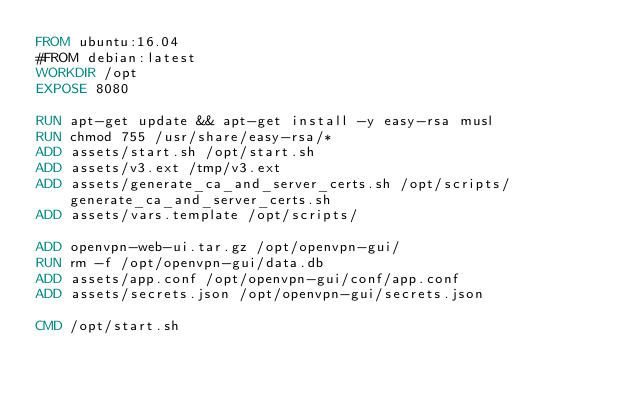<code> <loc_0><loc_0><loc_500><loc_500><_Dockerfile_>FROM ubuntu:16.04
#FROM debian:latest
WORKDIR /opt
EXPOSE 8080

RUN apt-get update && apt-get install -y easy-rsa musl
RUN chmod 755 /usr/share/easy-rsa/*
ADD assets/start.sh /opt/start.sh
ADD assets/v3.ext /tmp/v3.ext
ADD assets/generate_ca_and_server_certs.sh /opt/scripts/generate_ca_and_server_certs.sh
ADD assets/vars.template /opt/scripts/

ADD openvpn-web-ui.tar.gz /opt/openvpn-gui/
RUN rm -f /opt/openvpn-gui/data.db
ADD assets/app.conf /opt/openvpn-gui/conf/app.conf
ADD assets/secrets.json /opt/openvpn-gui/secrets.json

CMD /opt/start.sh
</code> 